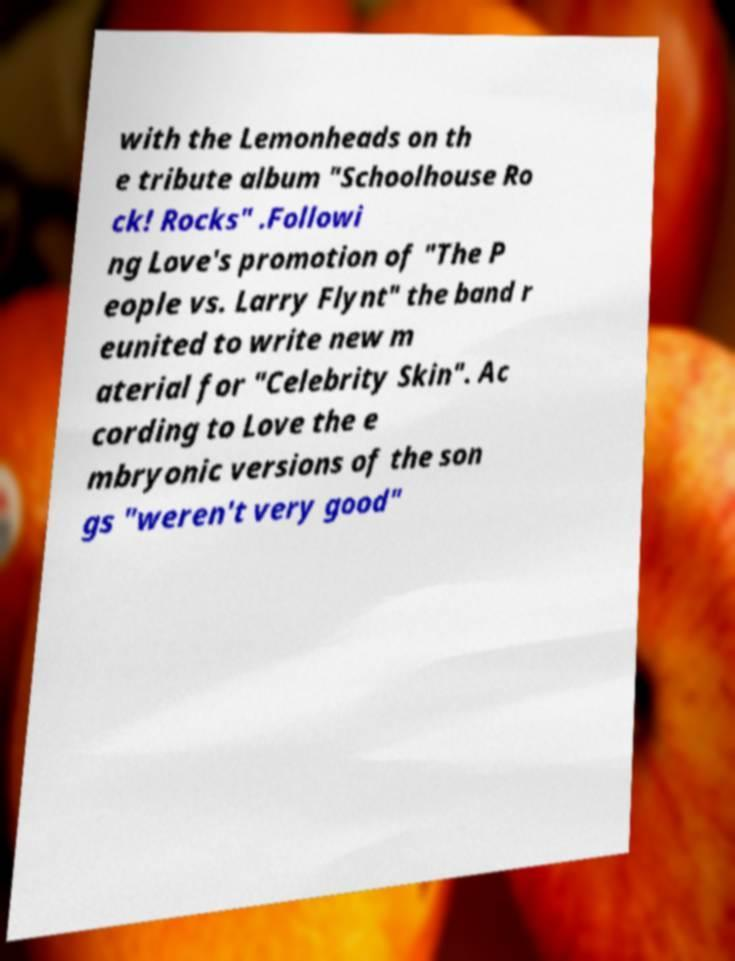I need the written content from this picture converted into text. Can you do that? with the Lemonheads on th e tribute album "Schoolhouse Ro ck! Rocks" .Followi ng Love's promotion of "The P eople vs. Larry Flynt" the band r eunited to write new m aterial for "Celebrity Skin". Ac cording to Love the e mbryonic versions of the son gs "weren't very good" 